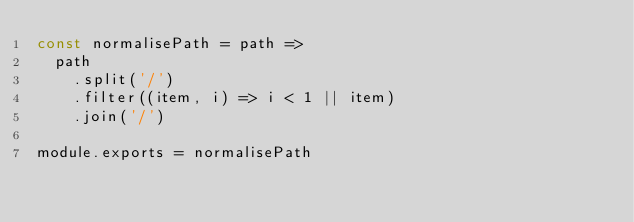<code> <loc_0><loc_0><loc_500><loc_500><_JavaScript_>const normalisePath = path =>
  path
    .split('/')
    .filter((item, i) => i < 1 || item)
    .join('/')

module.exports = normalisePath
</code> 